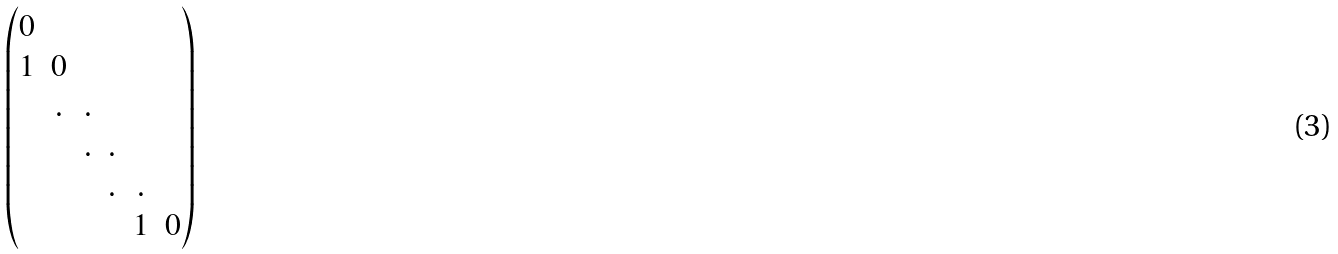<formula> <loc_0><loc_0><loc_500><loc_500>\begin{pmatrix} 0 & & & & & \\ 1 & 0 & & & & \\ & . & . & & & \\ & & . & . & & \\ & & & . & . & \\ & & & & 1 & 0 \\ \end{pmatrix}</formula> 